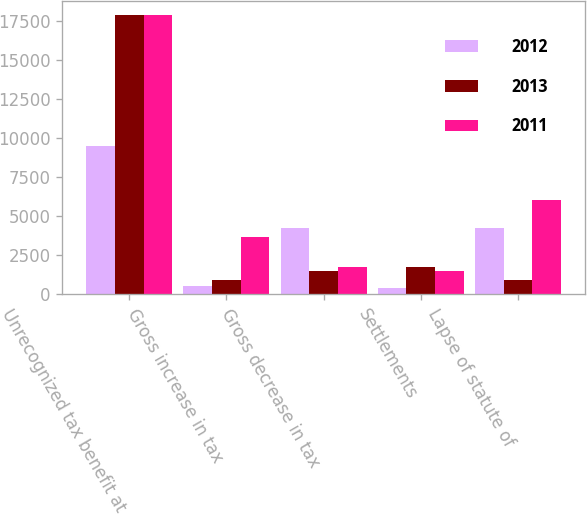Convert chart. <chart><loc_0><loc_0><loc_500><loc_500><stacked_bar_chart><ecel><fcel>Unrecognized tax benefit at<fcel>Gross increase in tax<fcel>Gross decrease in tax<fcel>Settlements<fcel>Lapse of statute of<nl><fcel>2012<fcel>9524<fcel>541<fcel>4241<fcel>390<fcel>4269<nl><fcel>2013<fcel>17883<fcel>911<fcel>1494<fcel>1770<fcel>945<nl><fcel>2011<fcel>17877<fcel>3684<fcel>1753<fcel>1477<fcel>6015<nl></chart> 